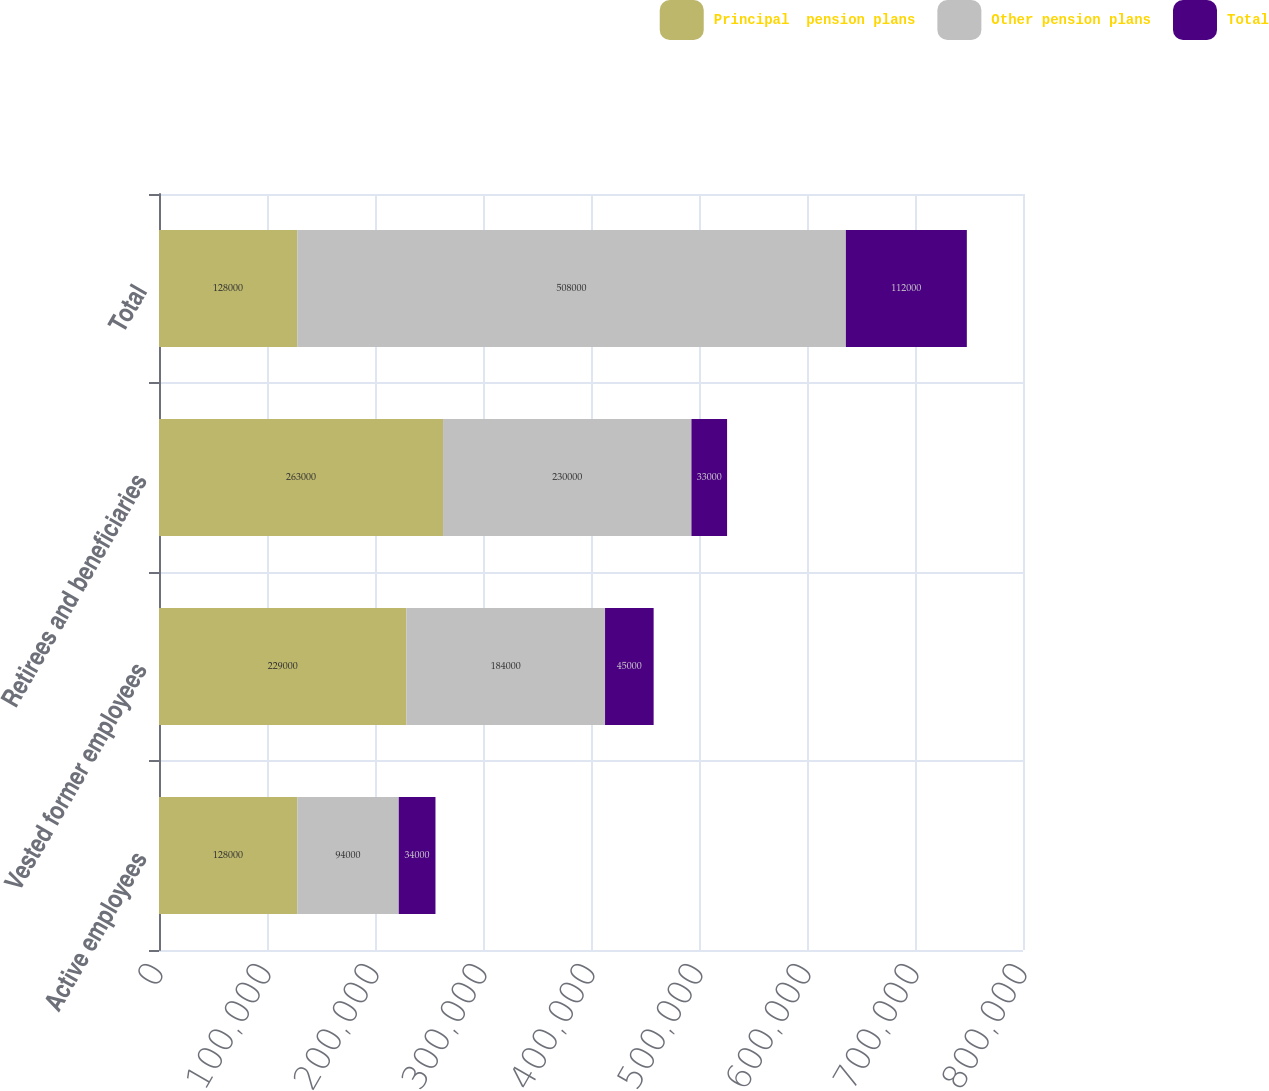<chart> <loc_0><loc_0><loc_500><loc_500><stacked_bar_chart><ecel><fcel>Active employees<fcel>Vested former employees<fcel>Retirees and beneficiaries<fcel>Total<nl><fcel>Principal  pension plans<fcel>128000<fcel>229000<fcel>263000<fcel>128000<nl><fcel>Other pension plans<fcel>94000<fcel>184000<fcel>230000<fcel>508000<nl><fcel>Total<fcel>34000<fcel>45000<fcel>33000<fcel>112000<nl></chart> 